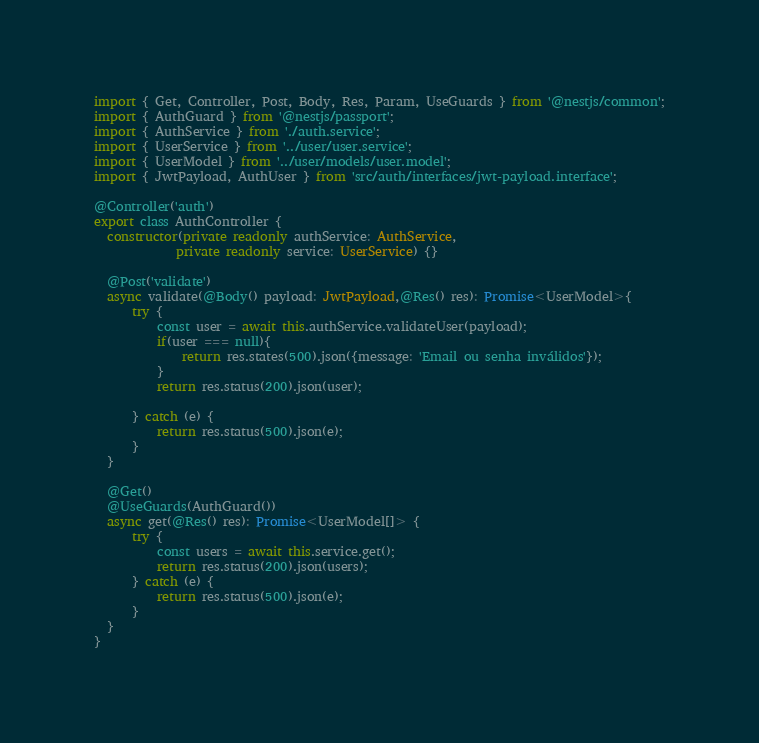Convert code to text. <code><loc_0><loc_0><loc_500><loc_500><_TypeScript_>import { Get, Controller, Post, Body, Res, Param, UseGuards } from '@nestjs/common';
import { AuthGuard } from '@nestjs/passport';
import { AuthService } from './auth.service';
import { UserService } from '../user/user.service';
import { UserModel } from '../user/models/user.model';
import { JwtPayload, AuthUser } from 'src/auth/interfaces/jwt-payload.interface';

@Controller('auth')
export class AuthController {
  constructor(private readonly authService: AuthService,
             private readonly service: UserService) {}

  @Post('validate')
  async validate(@Body() payload: JwtPayload,@Res() res): Promise<UserModel>{
      try {
          const user = await this.authService.validateUser(payload);
          if(user === null){
              return res.states(500).json({message: 'Email ou senha inválidos'});
          }
          return res.status(200).json(user);
          
      } catch (e) {
          return res.status(500).json(e);
      }
  }

  @Get()
  @UseGuards(AuthGuard())
  async get(@Res() res): Promise<UserModel[]> {
      try {
          const users = await this.service.get();
          return res.status(200).json(users);
      } catch (e) {
          return res.status(500).json(e);
      }
  }
}</code> 